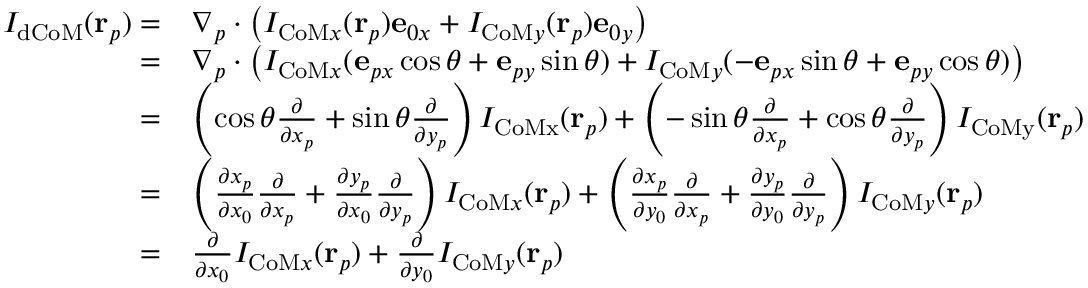Convert formula to latex. <formula><loc_0><loc_0><loc_500><loc_500>\begin{array} { r l } { I _ { d C o M } ( r _ { p } ) = } & { \nabla _ { p } \cdot \left ( I _ { C o M x } ( r _ { p } ) e _ { 0 x } + I _ { C o M y } ( r _ { p } ) e _ { 0 y } \right ) } \\ { = } & { \nabla _ { p } \cdot \left ( I _ { C o M x } ( e _ { p x } \cos \theta + e _ { p y } \sin \theta ) + I _ { C o M y } ( - e _ { p x } \sin \theta + e _ { p y } \cos \theta ) \right ) } \\ { = } & { \left ( \cos \theta \frac { \partial } { \partial x _ { p } } + \sin \theta \frac { \partial } { \partial y _ { p } } \right ) I _ { C o M x } ( r _ { p } ) + \left ( - \sin \theta \frac { \partial } { \partial x _ { p } } + \cos \theta \frac { \partial } { \partial y _ { p } } \right ) I _ { C o M y } ( r _ { p } ) } \\ { = } & { \left ( \frac { \partial x _ { p } } { \partial x _ { 0 } } \frac { \partial } { \partial x _ { p } } + \frac { \partial y _ { p } } { \partial x _ { 0 } } \frac { \partial } { \partial y _ { p } } \right ) I _ { C o M x } ( r _ { p } ) + \left ( \frac { \partial x _ { p } } { \partial y _ { 0 } } \frac { \partial } { \partial x _ { p } } + \frac { \partial y _ { p } } { \partial y _ { 0 } } \frac { \partial } { \partial y _ { p } } \right ) I _ { C o M y } ( r _ { p } ) } \\ { = } & { \frac { \partial } { \partial x _ { 0 } } I _ { C o M x } ( r _ { p } ) + \frac { \partial } { \partial y _ { 0 } } I _ { C o M y } ( r _ { p } ) } \end{array}</formula> 